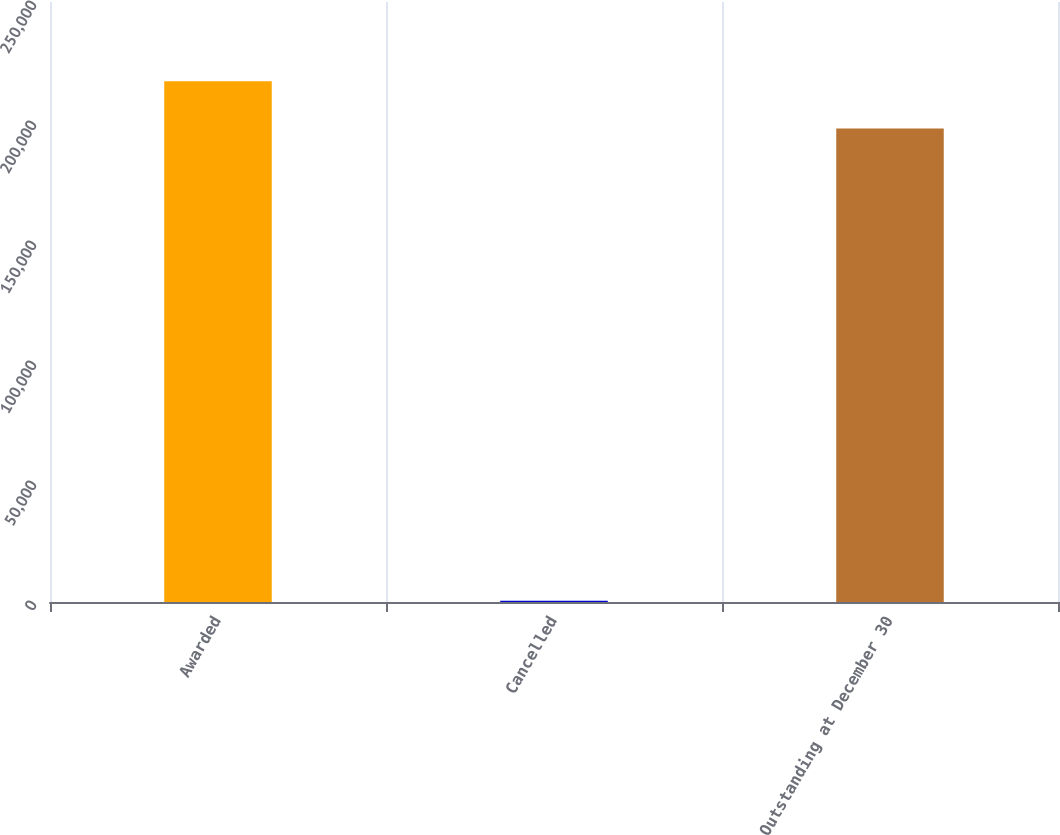<chart> <loc_0><loc_0><loc_500><loc_500><bar_chart><fcel>Awarded<fcel>Cancelled<fcel>Outstanding at December 30<nl><fcel>216975<fcel>500<fcel>197250<nl></chart> 